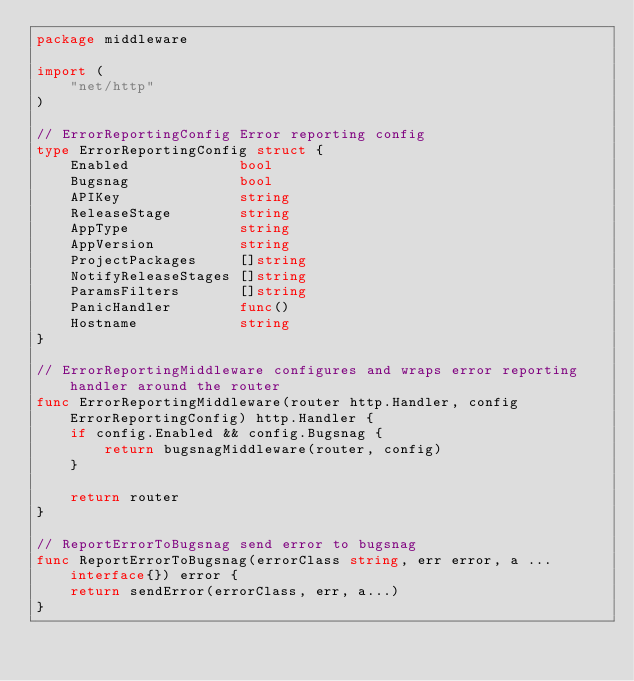<code> <loc_0><loc_0><loc_500><loc_500><_Go_>package middleware

import (
	"net/http"
)

// ErrorReportingConfig Error reporting config
type ErrorReportingConfig struct {
	Enabled             bool
	Bugsnag             bool
	APIKey              string
	ReleaseStage        string
	AppType             string
	AppVersion          string
	ProjectPackages     []string
	NotifyReleaseStages []string
	ParamsFilters       []string
	PanicHandler        func()
	Hostname            string
}

// ErrorReportingMiddleware configures and wraps error reporting handler around the router
func ErrorReportingMiddleware(router http.Handler, config ErrorReportingConfig) http.Handler {
	if config.Enabled && config.Bugsnag {
		return bugsnagMiddleware(router, config)
	}

	return router
}

// ReportErrorToBugsnag send error to bugsnag
func ReportErrorToBugsnag(errorClass string, err error, a ...interface{}) error {
	return sendError(errorClass, err, a...)
}
</code> 